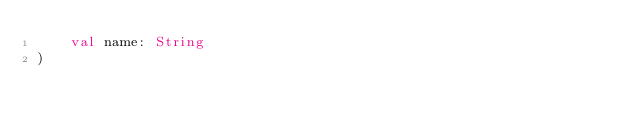Convert code to text. <code><loc_0><loc_0><loc_500><loc_500><_Kotlin_>    val name: String
)</code> 